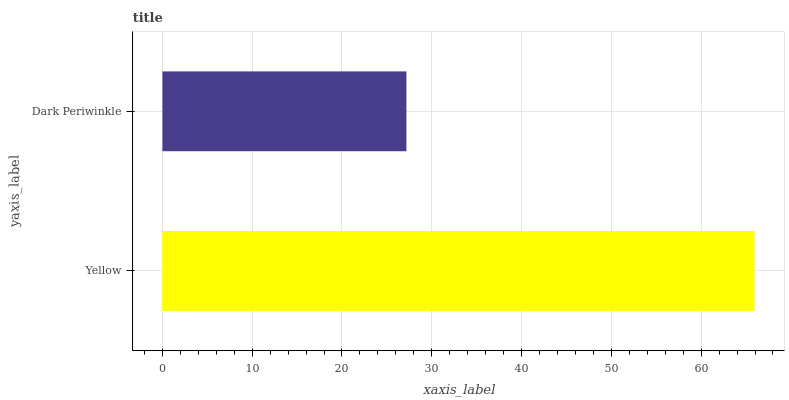Is Dark Periwinkle the minimum?
Answer yes or no. Yes. Is Yellow the maximum?
Answer yes or no. Yes. Is Dark Periwinkle the maximum?
Answer yes or no. No. Is Yellow greater than Dark Periwinkle?
Answer yes or no. Yes. Is Dark Periwinkle less than Yellow?
Answer yes or no. Yes. Is Dark Periwinkle greater than Yellow?
Answer yes or no. No. Is Yellow less than Dark Periwinkle?
Answer yes or no. No. Is Yellow the high median?
Answer yes or no. Yes. Is Dark Periwinkle the low median?
Answer yes or no. Yes. Is Dark Periwinkle the high median?
Answer yes or no. No. Is Yellow the low median?
Answer yes or no. No. 